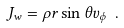Convert formula to latex. <formula><loc_0><loc_0><loc_500><loc_500>J _ { w } = \rho r \sin { \theta } v _ { \phi } \ .</formula> 